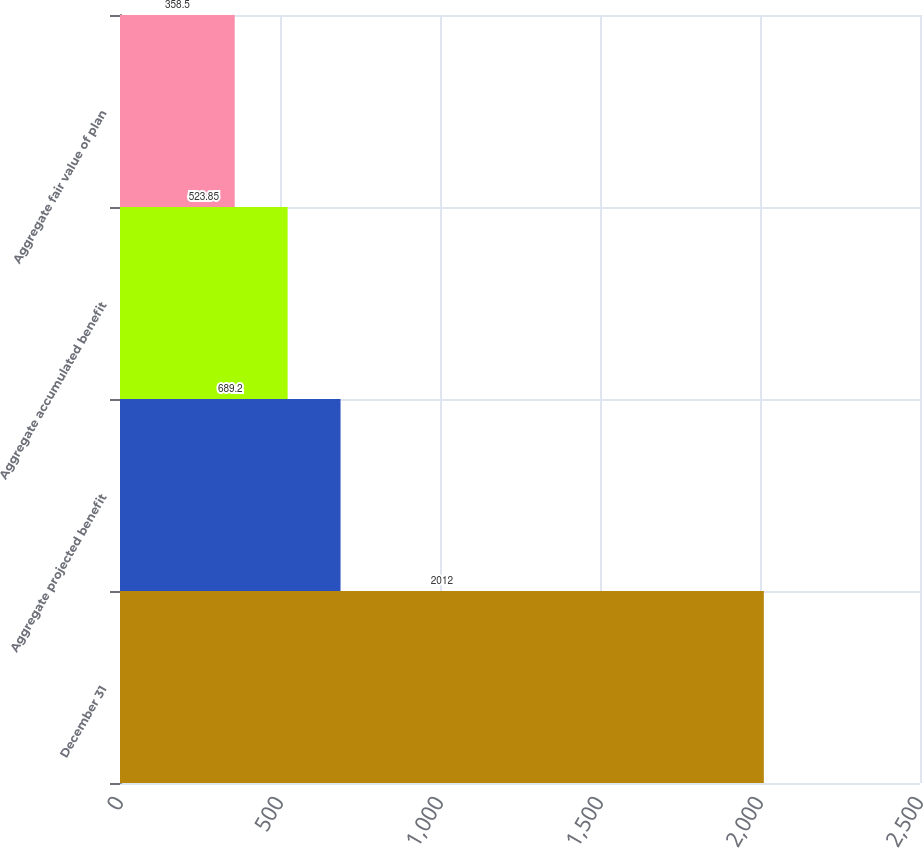<chart> <loc_0><loc_0><loc_500><loc_500><bar_chart><fcel>December 31<fcel>Aggregate projected benefit<fcel>Aggregate accumulated benefit<fcel>Aggregate fair value of plan<nl><fcel>2012<fcel>689.2<fcel>523.85<fcel>358.5<nl></chart> 